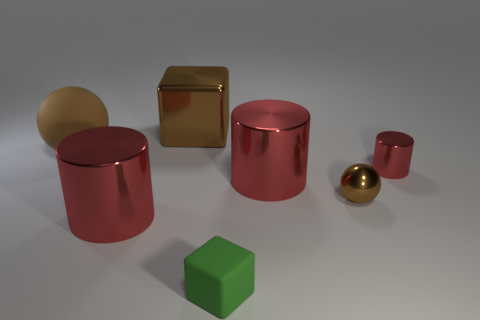There is a big matte thing; does it have the same color as the big shiny object in front of the tiny brown shiny object?
Make the answer very short. No. What color is the ball on the right side of the block on the left side of the small green matte object?
Ensure brevity in your answer.  Brown. What is the color of the shiny cylinder that is the same size as the brown metallic sphere?
Offer a terse response. Red. Are there any large brown metal objects of the same shape as the big matte thing?
Keep it short and to the point. No. There is a big brown matte object; what shape is it?
Your response must be concise. Sphere. Are there more big brown metallic things left of the large rubber sphere than brown metallic blocks behind the brown block?
Provide a succinct answer. No. What number of other objects are there of the same size as the rubber sphere?
Offer a very short reply. 3. What is the brown object that is both left of the brown metal sphere and to the right of the large matte object made of?
Your answer should be compact. Metal. What is the material of the other object that is the same shape as the tiny green object?
Your answer should be compact. Metal. There is a red object that is on the left side of the shiny thing that is behind the big ball; what number of objects are behind it?
Provide a succinct answer. 5. 